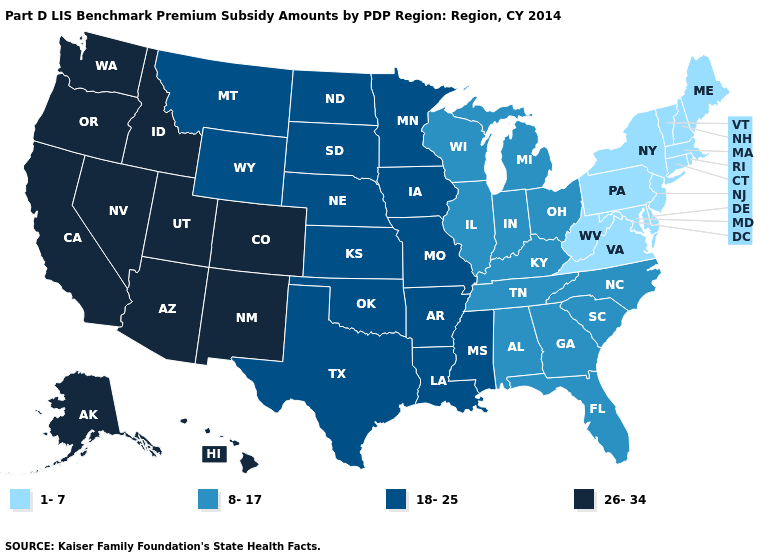What is the value of Pennsylvania?
Quick response, please. 1-7. What is the value of Arizona?
Keep it brief. 26-34. Does Arkansas have the same value as Iowa?
Answer briefly. Yes. What is the value of West Virginia?
Give a very brief answer. 1-7. Among the states that border Idaho , does Washington have the lowest value?
Short answer required. No. Does Louisiana have the highest value in the South?
Give a very brief answer. Yes. What is the highest value in the West ?
Answer briefly. 26-34. Does Indiana have the lowest value in the MidWest?
Be succinct. Yes. What is the lowest value in states that border Alabama?
Short answer required. 8-17. Does Kansas have a higher value than Arkansas?
Keep it brief. No. What is the highest value in the USA?
Write a very short answer. 26-34. What is the value of Washington?
Give a very brief answer. 26-34. How many symbols are there in the legend?
Quick response, please. 4. What is the value of Montana?
Concise answer only. 18-25. Does the first symbol in the legend represent the smallest category?
Concise answer only. Yes. 